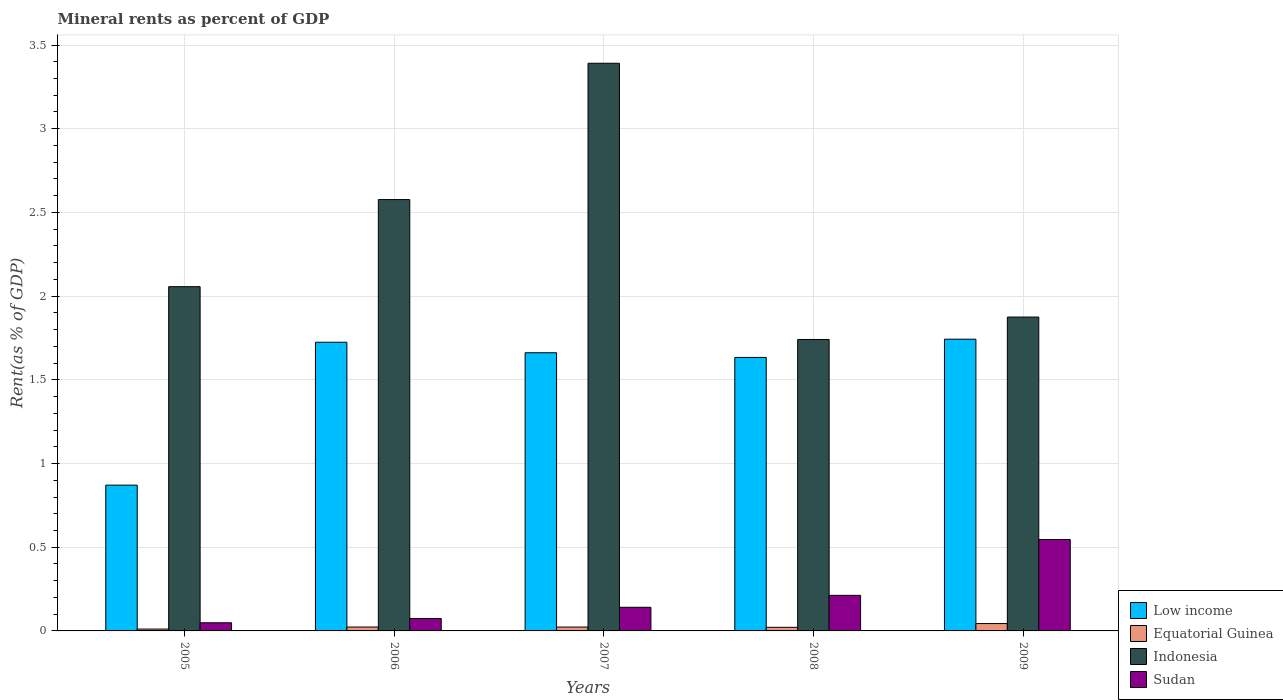How many different coloured bars are there?
Offer a terse response. 4. How many groups of bars are there?
Your response must be concise. 5. Are the number of bars on each tick of the X-axis equal?
Your answer should be compact. Yes. How many bars are there on the 5th tick from the left?
Ensure brevity in your answer.  4. What is the label of the 1st group of bars from the left?
Offer a terse response. 2005. In how many cases, is the number of bars for a given year not equal to the number of legend labels?
Give a very brief answer. 0. What is the mineral rent in Sudan in 2006?
Your answer should be compact. 0.07. Across all years, what is the maximum mineral rent in Equatorial Guinea?
Your response must be concise. 0.04. Across all years, what is the minimum mineral rent in Low income?
Make the answer very short. 0.87. What is the total mineral rent in Indonesia in the graph?
Offer a terse response. 11.64. What is the difference between the mineral rent in Sudan in 2006 and that in 2009?
Keep it short and to the point. -0.47. What is the difference between the mineral rent in Equatorial Guinea in 2008 and the mineral rent in Low income in 2006?
Make the answer very short. -1.7. What is the average mineral rent in Indonesia per year?
Your response must be concise. 2.33. In the year 2009, what is the difference between the mineral rent in Sudan and mineral rent in Low income?
Offer a terse response. -1.2. In how many years, is the mineral rent in Low income greater than 1.9 %?
Your answer should be very brief. 0. What is the ratio of the mineral rent in Equatorial Guinea in 2005 to that in 2006?
Offer a very short reply. 0.47. Is the mineral rent in Indonesia in 2008 less than that in 2009?
Your response must be concise. Yes. What is the difference between the highest and the second highest mineral rent in Equatorial Guinea?
Your response must be concise. 0.02. What is the difference between the highest and the lowest mineral rent in Sudan?
Your response must be concise. 0.5. In how many years, is the mineral rent in Equatorial Guinea greater than the average mineral rent in Equatorial Guinea taken over all years?
Offer a terse response. 1. Is the sum of the mineral rent in Sudan in 2008 and 2009 greater than the maximum mineral rent in Equatorial Guinea across all years?
Keep it short and to the point. Yes. Is it the case that in every year, the sum of the mineral rent in Indonesia and mineral rent in Sudan is greater than the sum of mineral rent in Low income and mineral rent in Equatorial Guinea?
Keep it short and to the point. No. What does the 1st bar from the left in 2008 represents?
Ensure brevity in your answer.  Low income. What does the 1st bar from the right in 2006 represents?
Offer a terse response. Sudan. Is it the case that in every year, the sum of the mineral rent in Sudan and mineral rent in Low income is greater than the mineral rent in Indonesia?
Provide a succinct answer. No. Are all the bars in the graph horizontal?
Provide a succinct answer. No. How many years are there in the graph?
Provide a succinct answer. 5. Does the graph contain any zero values?
Offer a terse response. No. Where does the legend appear in the graph?
Offer a very short reply. Bottom right. What is the title of the graph?
Provide a succinct answer. Mineral rents as percent of GDP. Does "Hong Kong" appear as one of the legend labels in the graph?
Make the answer very short. No. What is the label or title of the Y-axis?
Offer a very short reply. Rent(as % of GDP). What is the Rent(as % of GDP) of Low income in 2005?
Ensure brevity in your answer.  0.87. What is the Rent(as % of GDP) in Equatorial Guinea in 2005?
Make the answer very short. 0.01. What is the Rent(as % of GDP) of Indonesia in 2005?
Provide a succinct answer. 2.06. What is the Rent(as % of GDP) in Sudan in 2005?
Your answer should be compact. 0.05. What is the Rent(as % of GDP) in Low income in 2006?
Ensure brevity in your answer.  1.72. What is the Rent(as % of GDP) in Equatorial Guinea in 2006?
Keep it short and to the point. 0.02. What is the Rent(as % of GDP) of Indonesia in 2006?
Give a very brief answer. 2.58. What is the Rent(as % of GDP) of Sudan in 2006?
Your answer should be compact. 0.07. What is the Rent(as % of GDP) in Low income in 2007?
Your answer should be compact. 1.66. What is the Rent(as % of GDP) in Equatorial Guinea in 2007?
Make the answer very short. 0.02. What is the Rent(as % of GDP) of Indonesia in 2007?
Give a very brief answer. 3.39. What is the Rent(as % of GDP) in Sudan in 2007?
Your answer should be compact. 0.14. What is the Rent(as % of GDP) of Low income in 2008?
Your answer should be compact. 1.63. What is the Rent(as % of GDP) in Equatorial Guinea in 2008?
Give a very brief answer. 0.02. What is the Rent(as % of GDP) in Indonesia in 2008?
Ensure brevity in your answer.  1.74. What is the Rent(as % of GDP) of Sudan in 2008?
Provide a short and direct response. 0.21. What is the Rent(as % of GDP) in Low income in 2009?
Make the answer very short. 1.74. What is the Rent(as % of GDP) in Equatorial Guinea in 2009?
Provide a succinct answer. 0.04. What is the Rent(as % of GDP) of Indonesia in 2009?
Give a very brief answer. 1.87. What is the Rent(as % of GDP) of Sudan in 2009?
Your answer should be compact. 0.55. Across all years, what is the maximum Rent(as % of GDP) of Low income?
Offer a terse response. 1.74. Across all years, what is the maximum Rent(as % of GDP) of Equatorial Guinea?
Ensure brevity in your answer.  0.04. Across all years, what is the maximum Rent(as % of GDP) of Indonesia?
Make the answer very short. 3.39. Across all years, what is the maximum Rent(as % of GDP) of Sudan?
Ensure brevity in your answer.  0.55. Across all years, what is the minimum Rent(as % of GDP) in Low income?
Keep it short and to the point. 0.87. Across all years, what is the minimum Rent(as % of GDP) of Equatorial Guinea?
Your answer should be very brief. 0.01. Across all years, what is the minimum Rent(as % of GDP) in Indonesia?
Your answer should be very brief. 1.74. Across all years, what is the minimum Rent(as % of GDP) in Sudan?
Your answer should be very brief. 0.05. What is the total Rent(as % of GDP) in Low income in the graph?
Your answer should be compact. 7.63. What is the total Rent(as % of GDP) in Equatorial Guinea in the graph?
Make the answer very short. 0.12. What is the total Rent(as % of GDP) in Indonesia in the graph?
Provide a succinct answer. 11.64. What is the total Rent(as % of GDP) in Sudan in the graph?
Make the answer very short. 1.02. What is the difference between the Rent(as % of GDP) in Low income in 2005 and that in 2006?
Give a very brief answer. -0.85. What is the difference between the Rent(as % of GDP) in Equatorial Guinea in 2005 and that in 2006?
Your answer should be very brief. -0.01. What is the difference between the Rent(as % of GDP) in Indonesia in 2005 and that in 2006?
Your response must be concise. -0.52. What is the difference between the Rent(as % of GDP) of Sudan in 2005 and that in 2006?
Offer a very short reply. -0.03. What is the difference between the Rent(as % of GDP) of Low income in 2005 and that in 2007?
Make the answer very short. -0.79. What is the difference between the Rent(as % of GDP) of Equatorial Guinea in 2005 and that in 2007?
Your response must be concise. -0.01. What is the difference between the Rent(as % of GDP) in Indonesia in 2005 and that in 2007?
Make the answer very short. -1.33. What is the difference between the Rent(as % of GDP) in Sudan in 2005 and that in 2007?
Give a very brief answer. -0.09. What is the difference between the Rent(as % of GDP) in Low income in 2005 and that in 2008?
Your answer should be very brief. -0.76. What is the difference between the Rent(as % of GDP) in Equatorial Guinea in 2005 and that in 2008?
Your answer should be very brief. -0.01. What is the difference between the Rent(as % of GDP) of Indonesia in 2005 and that in 2008?
Make the answer very short. 0.32. What is the difference between the Rent(as % of GDP) in Sudan in 2005 and that in 2008?
Make the answer very short. -0.16. What is the difference between the Rent(as % of GDP) in Low income in 2005 and that in 2009?
Keep it short and to the point. -0.87. What is the difference between the Rent(as % of GDP) in Equatorial Guinea in 2005 and that in 2009?
Offer a very short reply. -0.03. What is the difference between the Rent(as % of GDP) in Indonesia in 2005 and that in 2009?
Your answer should be compact. 0.18. What is the difference between the Rent(as % of GDP) in Sudan in 2005 and that in 2009?
Ensure brevity in your answer.  -0.5. What is the difference between the Rent(as % of GDP) of Low income in 2006 and that in 2007?
Your answer should be compact. 0.06. What is the difference between the Rent(as % of GDP) in Equatorial Guinea in 2006 and that in 2007?
Give a very brief answer. 0. What is the difference between the Rent(as % of GDP) of Indonesia in 2006 and that in 2007?
Your answer should be very brief. -0.81. What is the difference between the Rent(as % of GDP) of Sudan in 2006 and that in 2007?
Offer a terse response. -0.07. What is the difference between the Rent(as % of GDP) in Low income in 2006 and that in 2008?
Provide a short and direct response. 0.09. What is the difference between the Rent(as % of GDP) in Equatorial Guinea in 2006 and that in 2008?
Your response must be concise. 0. What is the difference between the Rent(as % of GDP) in Indonesia in 2006 and that in 2008?
Your answer should be very brief. 0.84. What is the difference between the Rent(as % of GDP) in Sudan in 2006 and that in 2008?
Your answer should be compact. -0.14. What is the difference between the Rent(as % of GDP) in Low income in 2006 and that in 2009?
Your response must be concise. -0.02. What is the difference between the Rent(as % of GDP) in Equatorial Guinea in 2006 and that in 2009?
Your answer should be very brief. -0.02. What is the difference between the Rent(as % of GDP) of Indonesia in 2006 and that in 2009?
Make the answer very short. 0.7. What is the difference between the Rent(as % of GDP) in Sudan in 2006 and that in 2009?
Provide a short and direct response. -0.47. What is the difference between the Rent(as % of GDP) in Low income in 2007 and that in 2008?
Your answer should be compact. 0.03. What is the difference between the Rent(as % of GDP) of Equatorial Guinea in 2007 and that in 2008?
Your response must be concise. 0. What is the difference between the Rent(as % of GDP) in Indonesia in 2007 and that in 2008?
Provide a short and direct response. 1.65. What is the difference between the Rent(as % of GDP) in Sudan in 2007 and that in 2008?
Your answer should be very brief. -0.07. What is the difference between the Rent(as % of GDP) in Low income in 2007 and that in 2009?
Give a very brief answer. -0.08. What is the difference between the Rent(as % of GDP) of Equatorial Guinea in 2007 and that in 2009?
Your answer should be compact. -0.02. What is the difference between the Rent(as % of GDP) of Indonesia in 2007 and that in 2009?
Your answer should be compact. 1.52. What is the difference between the Rent(as % of GDP) in Sudan in 2007 and that in 2009?
Offer a very short reply. -0.41. What is the difference between the Rent(as % of GDP) of Low income in 2008 and that in 2009?
Give a very brief answer. -0.11. What is the difference between the Rent(as % of GDP) of Equatorial Guinea in 2008 and that in 2009?
Make the answer very short. -0.02. What is the difference between the Rent(as % of GDP) of Indonesia in 2008 and that in 2009?
Make the answer very short. -0.13. What is the difference between the Rent(as % of GDP) in Sudan in 2008 and that in 2009?
Give a very brief answer. -0.33. What is the difference between the Rent(as % of GDP) of Low income in 2005 and the Rent(as % of GDP) of Equatorial Guinea in 2006?
Your response must be concise. 0.85. What is the difference between the Rent(as % of GDP) of Low income in 2005 and the Rent(as % of GDP) of Indonesia in 2006?
Provide a short and direct response. -1.71. What is the difference between the Rent(as % of GDP) of Low income in 2005 and the Rent(as % of GDP) of Sudan in 2006?
Your response must be concise. 0.8. What is the difference between the Rent(as % of GDP) of Equatorial Guinea in 2005 and the Rent(as % of GDP) of Indonesia in 2006?
Your answer should be very brief. -2.57. What is the difference between the Rent(as % of GDP) in Equatorial Guinea in 2005 and the Rent(as % of GDP) in Sudan in 2006?
Your answer should be very brief. -0.06. What is the difference between the Rent(as % of GDP) in Indonesia in 2005 and the Rent(as % of GDP) in Sudan in 2006?
Offer a very short reply. 1.98. What is the difference between the Rent(as % of GDP) in Low income in 2005 and the Rent(as % of GDP) in Equatorial Guinea in 2007?
Your answer should be very brief. 0.85. What is the difference between the Rent(as % of GDP) of Low income in 2005 and the Rent(as % of GDP) of Indonesia in 2007?
Offer a very short reply. -2.52. What is the difference between the Rent(as % of GDP) of Low income in 2005 and the Rent(as % of GDP) of Sudan in 2007?
Your answer should be compact. 0.73. What is the difference between the Rent(as % of GDP) of Equatorial Guinea in 2005 and the Rent(as % of GDP) of Indonesia in 2007?
Provide a short and direct response. -3.38. What is the difference between the Rent(as % of GDP) in Equatorial Guinea in 2005 and the Rent(as % of GDP) in Sudan in 2007?
Your response must be concise. -0.13. What is the difference between the Rent(as % of GDP) in Indonesia in 2005 and the Rent(as % of GDP) in Sudan in 2007?
Make the answer very short. 1.92. What is the difference between the Rent(as % of GDP) of Low income in 2005 and the Rent(as % of GDP) of Equatorial Guinea in 2008?
Ensure brevity in your answer.  0.85. What is the difference between the Rent(as % of GDP) in Low income in 2005 and the Rent(as % of GDP) in Indonesia in 2008?
Ensure brevity in your answer.  -0.87. What is the difference between the Rent(as % of GDP) in Low income in 2005 and the Rent(as % of GDP) in Sudan in 2008?
Ensure brevity in your answer.  0.66. What is the difference between the Rent(as % of GDP) of Equatorial Guinea in 2005 and the Rent(as % of GDP) of Indonesia in 2008?
Your answer should be compact. -1.73. What is the difference between the Rent(as % of GDP) in Equatorial Guinea in 2005 and the Rent(as % of GDP) in Sudan in 2008?
Provide a short and direct response. -0.2. What is the difference between the Rent(as % of GDP) in Indonesia in 2005 and the Rent(as % of GDP) in Sudan in 2008?
Provide a succinct answer. 1.84. What is the difference between the Rent(as % of GDP) in Low income in 2005 and the Rent(as % of GDP) in Equatorial Guinea in 2009?
Keep it short and to the point. 0.83. What is the difference between the Rent(as % of GDP) in Low income in 2005 and the Rent(as % of GDP) in Indonesia in 2009?
Provide a short and direct response. -1. What is the difference between the Rent(as % of GDP) of Low income in 2005 and the Rent(as % of GDP) of Sudan in 2009?
Provide a short and direct response. 0.32. What is the difference between the Rent(as % of GDP) in Equatorial Guinea in 2005 and the Rent(as % of GDP) in Indonesia in 2009?
Offer a very short reply. -1.86. What is the difference between the Rent(as % of GDP) of Equatorial Guinea in 2005 and the Rent(as % of GDP) of Sudan in 2009?
Ensure brevity in your answer.  -0.54. What is the difference between the Rent(as % of GDP) in Indonesia in 2005 and the Rent(as % of GDP) in Sudan in 2009?
Make the answer very short. 1.51. What is the difference between the Rent(as % of GDP) in Low income in 2006 and the Rent(as % of GDP) in Equatorial Guinea in 2007?
Offer a very short reply. 1.7. What is the difference between the Rent(as % of GDP) in Low income in 2006 and the Rent(as % of GDP) in Indonesia in 2007?
Ensure brevity in your answer.  -1.67. What is the difference between the Rent(as % of GDP) in Low income in 2006 and the Rent(as % of GDP) in Sudan in 2007?
Keep it short and to the point. 1.58. What is the difference between the Rent(as % of GDP) of Equatorial Guinea in 2006 and the Rent(as % of GDP) of Indonesia in 2007?
Your response must be concise. -3.37. What is the difference between the Rent(as % of GDP) of Equatorial Guinea in 2006 and the Rent(as % of GDP) of Sudan in 2007?
Give a very brief answer. -0.12. What is the difference between the Rent(as % of GDP) in Indonesia in 2006 and the Rent(as % of GDP) in Sudan in 2007?
Ensure brevity in your answer.  2.44. What is the difference between the Rent(as % of GDP) in Low income in 2006 and the Rent(as % of GDP) in Equatorial Guinea in 2008?
Ensure brevity in your answer.  1.7. What is the difference between the Rent(as % of GDP) in Low income in 2006 and the Rent(as % of GDP) in Indonesia in 2008?
Ensure brevity in your answer.  -0.02. What is the difference between the Rent(as % of GDP) in Low income in 2006 and the Rent(as % of GDP) in Sudan in 2008?
Your response must be concise. 1.51. What is the difference between the Rent(as % of GDP) in Equatorial Guinea in 2006 and the Rent(as % of GDP) in Indonesia in 2008?
Provide a short and direct response. -1.72. What is the difference between the Rent(as % of GDP) in Equatorial Guinea in 2006 and the Rent(as % of GDP) in Sudan in 2008?
Provide a short and direct response. -0.19. What is the difference between the Rent(as % of GDP) in Indonesia in 2006 and the Rent(as % of GDP) in Sudan in 2008?
Make the answer very short. 2.36. What is the difference between the Rent(as % of GDP) of Low income in 2006 and the Rent(as % of GDP) of Equatorial Guinea in 2009?
Provide a short and direct response. 1.68. What is the difference between the Rent(as % of GDP) in Low income in 2006 and the Rent(as % of GDP) in Indonesia in 2009?
Your answer should be compact. -0.15. What is the difference between the Rent(as % of GDP) of Low income in 2006 and the Rent(as % of GDP) of Sudan in 2009?
Make the answer very short. 1.18. What is the difference between the Rent(as % of GDP) in Equatorial Guinea in 2006 and the Rent(as % of GDP) in Indonesia in 2009?
Offer a terse response. -1.85. What is the difference between the Rent(as % of GDP) of Equatorial Guinea in 2006 and the Rent(as % of GDP) of Sudan in 2009?
Ensure brevity in your answer.  -0.52. What is the difference between the Rent(as % of GDP) in Indonesia in 2006 and the Rent(as % of GDP) in Sudan in 2009?
Your answer should be very brief. 2.03. What is the difference between the Rent(as % of GDP) of Low income in 2007 and the Rent(as % of GDP) of Equatorial Guinea in 2008?
Ensure brevity in your answer.  1.64. What is the difference between the Rent(as % of GDP) in Low income in 2007 and the Rent(as % of GDP) in Indonesia in 2008?
Make the answer very short. -0.08. What is the difference between the Rent(as % of GDP) in Low income in 2007 and the Rent(as % of GDP) in Sudan in 2008?
Your answer should be compact. 1.45. What is the difference between the Rent(as % of GDP) of Equatorial Guinea in 2007 and the Rent(as % of GDP) of Indonesia in 2008?
Offer a very short reply. -1.72. What is the difference between the Rent(as % of GDP) of Equatorial Guinea in 2007 and the Rent(as % of GDP) of Sudan in 2008?
Offer a terse response. -0.19. What is the difference between the Rent(as % of GDP) of Indonesia in 2007 and the Rent(as % of GDP) of Sudan in 2008?
Offer a terse response. 3.18. What is the difference between the Rent(as % of GDP) in Low income in 2007 and the Rent(as % of GDP) in Equatorial Guinea in 2009?
Your answer should be very brief. 1.62. What is the difference between the Rent(as % of GDP) of Low income in 2007 and the Rent(as % of GDP) of Indonesia in 2009?
Ensure brevity in your answer.  -0.21. What is the difference between the Rent(as % of GDP) of Low income in 2007 and the Rent(as % of GDP) of Sudan in 2009?
Offer a terse response. 1.12. What is the difference between the Rent(as % of GDP) of Equatorial Guinea in 2007 and the Rent(as % of GDP) of Indonesia in 2009?
Give a very brief answer. -1.85. What is the difference between the Rent(as % of GDP) of Equatorial Guinea in 2007 and the Rent(as % of GDP) of Sudan in 2009?
Offer a terse response. -0.52. What is the difference between the Rent(as % of GDP) of Indonesia in 2007 and the Rent(as % of GDP) of Sudan in 2009?
Keep it short and to the point. 2.84. What is the difference between the Rent(as % of GDP) in Low income in 2008 and the Rent(as % of GDP) in Equatorial Guinea in 2009?
Make the answer very short. 1.59. What is the difference between the Rent(as % of GDP) in Low income in 2008 and the Rent(as % of GDP) in Indonesia in 2009?
Provide a succinct answer. -0.24. What is the difference between the Rent(as % of GDP) of Low income in 2008 and the Rent(as % of GDP) of Sudan in 2009?
Make the answer very short. 1.09. What is the difference between the Rent(as % of GDP) of Equatorial Guinea in 2008 and the Rent(as % of GDP) of Indonesia in 2009?
Provide a short and direct response. -1.85. What is the difference between the Rent(as % of GDP) in Equatorial Guinea in 2008 and the Rent(as % of GDP) in Sudan in 2009?
Your response must be concise. -0.52. What is the difference between the Rent(as % of GDP) in Indonesia in 2008 and the Rent(as % of GDP) in Sudan in 2009?
Your answer should be compact. 1.19. What is the average Rent(as % of GDP) in Low income per year?
Make the answer very short. 1.53. What is the average Rent(as % of GDP) in Equatorial Guinea per year?
Keep it short and to the point. 0.02. What is the average Rent(as % of GDP) of Indonesia per year?
Provide a short and direct response. 2.33. What is the average Rent(as % of GDP) of Sudan per year?
Provide a short and direct response. 0.2. In the year 2005, what is the difference between the Rent(as % of GDP) in Low income and Rent(as % of GDP) in Equatorial Guinea?
Keep it short and to the point. 0.86. In the year 2005, what is the difference between the Rent(as % of GDP) of Low income and Rent(as % of GDP) of Indonesia?
Keep it short and to the point. -1.19. In the year 2005, what is the difference between the Rent(as % of GDP) of Low income and Rent(as % of GDP) of Sudan?
Ensure brevity in your answer.  0.82. In the year 2005, what is the difference between the Rent(as % of GDP) of Equatorial Guinea and Rent(as % of GDP) of Indonesia?
Keep it short and to the point. -2.05. In the year 2005, what is the difference between the Rent(as % of GDP) in Equatorial Guinea and Rent(as % of GDP) in Sudan?
Make the answer very short. -0.04. In the year 2005, what is the difference between the Rent(as % of GDP) of Indonesia and Rent(as % of GDP) of Sudan?
Offer a very short reply. 2.01. In the year 2006, what is the difference between the Rent(as % of GDP) of Low income and Rent(as % of GDP) of Equatorial Guinea?
Provide a succinct answer. 1.7. In the year 2006, what is the difference between the Rent(as % of GDP) in Low income and Rent(as % of GDP) in Indonesia?
Ensure brevity in your answer.  -0.85. In the year 2006, what is the difference between the Rent(as % of GDP) in Low income and Rent(as % of GDP) in Sudan?
Offer a very short reply. 1.65. In the year 2006, what is the difference between the Rent(as % of GDP) of Equatorial Guinea and Rent(as % of GDP) of Indonesia?
Your answer should be very brief. -2.55. In the year 2006, what is the difference between the Rent(as % of GDP) in Equatorial Guinea and Rent(as % of GDP) in Sudan?
Make the answer very short. -0.05. In the year 2006, what is the difference between the Rent(as % of GDP) in Indonesia and Rent(as % of GDP) in Sudan?
Keep it short and to the point. 2.5. In the year 2007, what is the difference between the Rent(as % of GDP) of Low income and Rent(as % of GDP) of Equatorial Guinea?
Provide a short and direct response. 1.64. In the year 2007, what is the difference between the Rent(as % of GDP) in Low income and Rent(as % of GDP) in Indonesia?
Make the answer very short. -1.73. In the year 2007, what is the difference between the Rent(as % of GDP) of Low income and Rent(as % of GDP) of Sudan?
Your answer should be compact. 1.52. In the year 2007, what is the difference between the Rent(as % of GDP) of Equatorial Guinea and Rent(as % of GDP) of Indonesia?
Offer a very short reply. -3.37. In the year 2007, what is the difference between the Rent(as % of GDP) in Equatorial Guinea and Rent(as % of GDP) in Sudan?
Ensure brevity in your answer.  -0.12. In the year 2007, what is the difference between the Rent(as % of GDP) of Indonesia and Rent(as % of GDP) of Sudan?
Your answer should be compact. 3.25. In the year 2008, what is the difference between the Rent(as % of GDP) of Low income and Rent(as % of GDP) of Equatorial Guinea?
Keep it short and to the point. 1.61. In the year 2008, what is the difference between the Rent(as % of GDP) in Low income and Rent(as % of GDP) in Indonesia?
Your answer should be very brief. -0.11. In the year 2008, what is the difference between the Rent(as % of GDP) in Low income and Rent(as % of GDP) in Sudan?
Provide a succinct answer. 1.42. In the year 2008, what is the difference between the Rent(as % of GDP) in Equatorial Guinea and Rent(as % of GDP) in Indonesia?
Offer a terse response. -1.72. In the year 2008, what is the difference between the Rent(as % of GDP) in Equatorial Guinea and Rent(as % of GDP) in Sudan?
Your answer should be very brief. -0.19. In the year 2008, what is the difference between the Rent(as % of GDP) in Indonesia and Rent(as % of GDP) in Sudan?
Keep it short and to the point. 1.53. In the year 2009, what is the difference between the Rent(as % of GDP) in Low income and Rent(as % of GDP) in Equatorial Guinea?
Make the answer very short. 1.7. In the year 2009, what is the difference between the Rent(as % of GDP) in Low income and Rent(as % of GDP) in Indonesia?
Make the answer very short. -0.13. In the year 2009, what is the difference between the Rent(as % of GDP) in Low income and Rent(as % of GDP) in Sudan?
Offer a terse response. 1.2. In the year 2009, what is the difference between the Rent(as % of GDP) in Equatorial Guinea and Rent(as % of GDP) in Indonesia?
Your answer should be very brief. -1.83. In the year 2009, what is the difference between the Rent(as % of GDP) of Equatorial Guinea and Rent(as % of GDP) of Sudan?
Keep it short and to the point. -0.5. In the year 2009, what is the difference between the Rent(as % of GDP) of Indonesia and Rent(as % of GDP) of Sudan?
Provide a succinct answer. 1.33. What is the ratio of the Rent(as % of GDP) in Low income in 2005 to that in 2006?
Offer a terse response. 0.51. What is the ratio of the Rent(as % of GDP) in Equatorial Guinea in 2005 to that in 2006?
Give a very brief answer. 0.47. What is the ratio of the Rent(as % of GDP) of Indonesia in 2005 to that in 2006?
Provide a succinct answer. 0.8. What is the ratio of the Rent(as % of GDP) of Sudan in 2005 to that in 2006?
Your response must be concise. 0.66. What is the ratio of the Rent(as % of GDP) of Low income in 2005 to that in 2007?
Make the answer very short. 0.52. What is the ratio of the Rent(as % of GDP) in Equatorial Guinea in 2005 to that in 2007?
Your response must be concise. 0.48. What is the ratio of the Rent(as % of GDP) of Indonesia in 2005 to that in 2007?
Offer a very short reply. 0.61. What is the ratio of the Rent(as % of GDP) of Sudan in 2005 to that in 2007?
Give a very brief answer. 0.34. What is the ratio of the Rent(as % of GDP) of Low income in 2005 to that in 2008?
Your answer should be very brief. 0.53. What is the ratio of the Rent(as % of GDP) of Equatorial Guinea in 2005 to that in 2008?
Give a very brief answer. 0.51. What is the ratio of the Rent(as % of GDP) in Indonesia in 2005 to that in 2008?
Make the answer very short. 1.18. What is the ratio of the Rent(as % of GDP) of Sudan in 2005 to that in 2008?
Ensure brevity in your answer.  0.23. What is the ratio of the Rent(as % of GDP) in Low income in 2005 to that in 2009?
Your answer should be compact. 0.5. What is the ratio of the Rent(as % of GDP) of Equatorial Guinea in 2005 to that in 2009?
Provide a short and direct response. 0.25. What is the ratio of the Rent(as % of GDP) of Indonesia in 2005 to that in 2009?
Ensure brevity in your answer.  1.1. What is the ratio of the Rent(as % of GDP) of Sudan in 2005 to that in 2009?
Offer a very short reply. 0.09. What is the ratio of the Rent(as % of GDP) in Low income in 2006 to that in 2007?
Your answer should be very brief. 1.04. What is the ratio of the Rent(as % of GDP) of Equatorial Guinea in 2006 to that in 2007?
Ensure brevity in your answer.  1.01. What is the ratio of the Rent(as % of GDP) in Indonesia in 2006 to that in 2007?
Offer a terse response. 0.76. What is the ratio of the Rent(as % of GDP) of Sudan in 2006 to that in 2007?
Provide a short and direct response. 0.53. What is the ratio of the Rent(as % of GDP) of Low income in 2006 to that in 2008?
Make the answer very short. 1.06. What is the ratio of the Rent(as % of GDP) of Equatorial Guinea in 2006 to that in 2008?
Provide a succinct answer. 1.08. What is the ratio of the Rent(as % of GDP) in Indonesia in 2006 to that in 2008?
Keep it short and to the point. 1.48. What is the ratio of the Rent(as % of GDP) in Sudan in 2006 to that in 2008?
Ensure brevity in your answer.  0.35. What is the ratio of the Rent(as % of GDP) in Equatorial Guinea in 2006 to that in 2009?
Provide a short and direct response. 0.53. What is the ratio of the Rent(as % of GDP) of Indonesia in 2006 to that in 2009?
Keep it short and to the point. 1.37. What is the ratio of the Rent(as % of GDP) in Sudan in 2006 to that in 2009?
Give a very brief answer. 0.14. What is the ratio of the Rent(as % of GDP) in Low income in 2007 to that in 2008?
Your answer should be compact. 1.02. What is the ratio of the Rent(as % of GDP) in Equatorial Guinea in 2007 to that in 2008?
Make the answer very short. 1.08. What is the ratio of the Rent(as % of GDP) of Indonesia in 2007 to that in 2008?
Offer a terse response. 1.95. What is the ratio of the Rent(as % of GDP) of Sudan in 2007 to that in 2008?
Offer a very short reply. 0.66. What is the ratio of the Rent(as % of GDP) in Low income in 2007 to that in 2009?
Keep it short and to the point. 0.95. What is the ratio of the Rent(as % of GDP) in Equatorial Guinea in 2007 to that in 2009?
Your answer should be very brief. 0.53. What is the ratio of the Rent(as % of GDP) in Indonesia in 2007 to that in 2009?
Your answer should be very brief. 1.81. What is the ratio of the Rent(as % of GDP) in Sudan in 2007 to that in 2009?
Your answer should be very brief. 0.26. What is the ratio of the Rent(as % of GDP) in Low income in 2008 to that in 2009?
Offer a terse response. 0.94. What is the ratio of the Rent(as % of GDP) in Equatorial Guinea in 2008 to that in 2009?
Your answer should be compact. 0.49. What is the ratio of the Rent(as % of GDP) in Indonesia in 2008 to that in 2009?
Give a very brief answer. 0.93. What is the ratio of the Rent(as % of GDP) in Sudan in 2008 to that in 2009?
Keep it short and to the point. 0.39. What is the difference between the highest and the second highest Rent(as % of GDP) in Low income?
Provide a short and direct response. 0.02. What is the difference between the highest and the second highest Rent(as % of GDP) in Equatorial Guinea?
Provide a short and direct response. 0.02. What is the difference between the highest and the second highest Rent(as % of GDP) of Indonesia?
Give a very brief answer. 0.81. What is the difference between the highest and the second highest Rent(as % of GDP) of Sudan?
Your answer should be very brief. 0.33. What is the difference between the highest and the lowest Rent(as % of GDP) of Low income?
Your answer should be compact. 0.87. What is the difference between the highest and the lowest Rent(as % of GDP) of Equatorial Guinea?
Ensure brevity in your answer.  0.03. What is the difference between the highest and the lowest Rent(as % of GDP) in Indonesia?
Provide a short and direct response. 1.65. What is the difference between the highest and the lowest Rent(as % of GDP) of Sudan?
Provide a succinct answer. 0.5. 